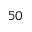Convert formula to latex. <formula><loc_0><loc_0><loc_500><loc_500>5 0</formula> 